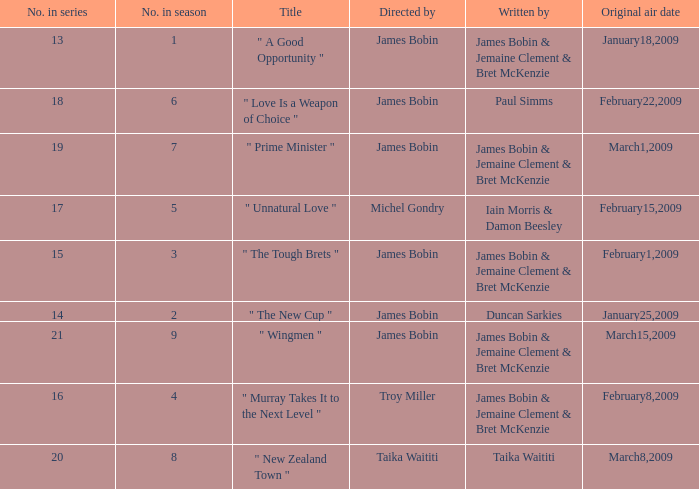 what's the title where original air date is january18,2009 " A Good Opportunity ". 